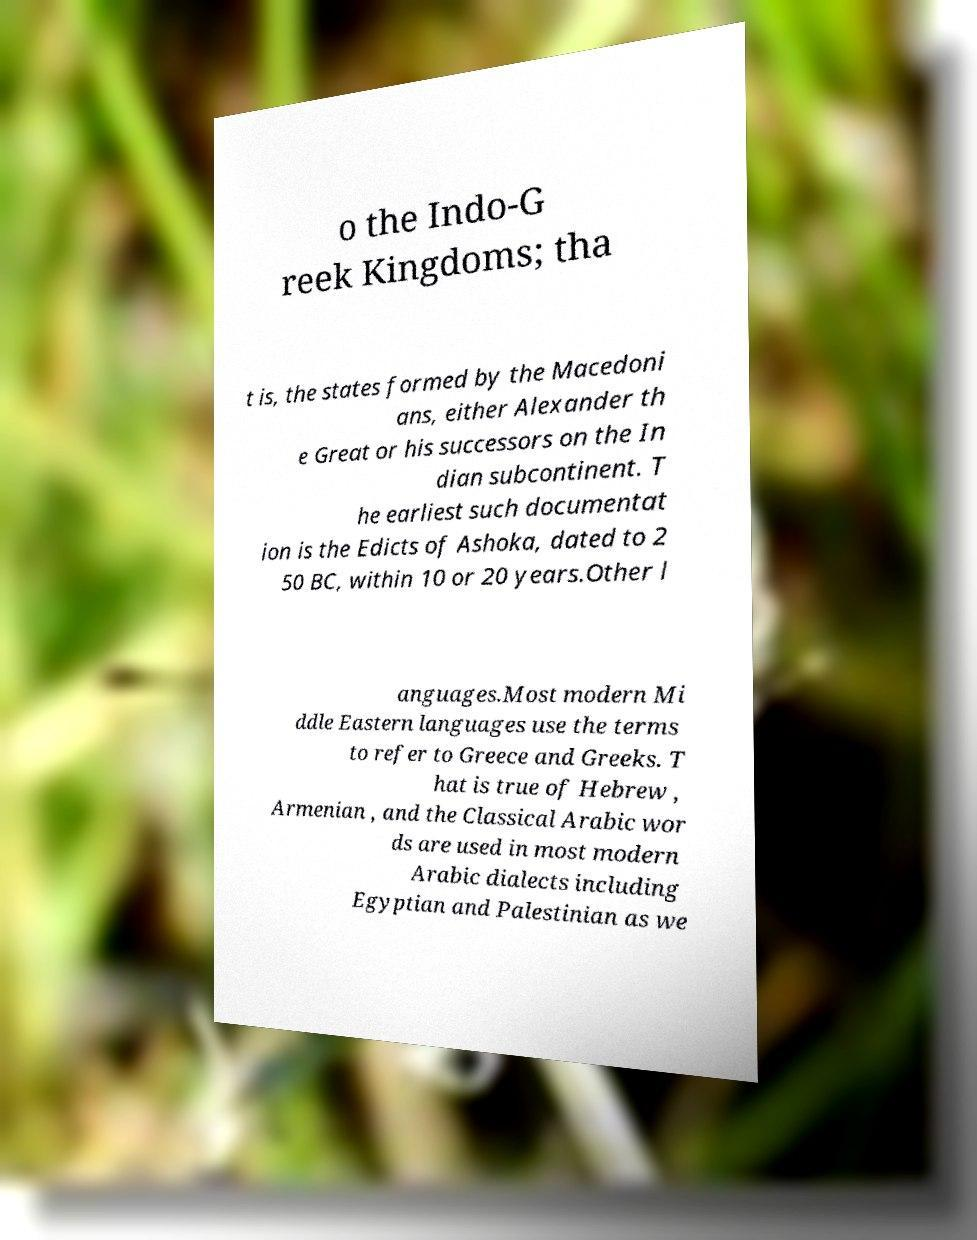There's text embedded in this image that I need extracted. Can you transcribe it verbatim? o the Indo-G reek Kingdoms; tha t is, the states formed by the Macedoni ans, either Alexander th e Great or his successors on the In dian subcontinent. T he earliest such documentat ion is the Edicts of Ashoka, dated to 2 50 BC, within 10 or 20 years.Other l anguages.Most modern Mi ddle Eastern languages use the terms to refer to Greece and Greeks. T hat is true of Hebrew , Armenian , and the Classical Arabic wor ds are used in most modern Arabic dialects including Egyptian and Palestinian as we 